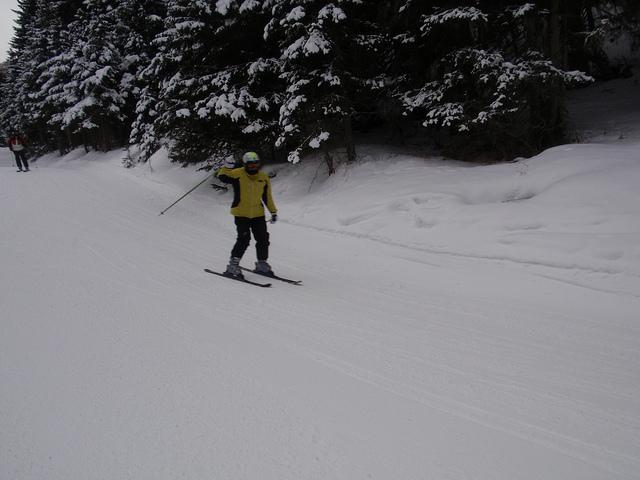What is behind the person?
Short answer required. Trees. What color is this person's jacket?
Concise answer only. Yellow. Is this a ski slope?
Write a very short answer. Yes. What color is the persons coat?
Quick response, please. Yellow. Is there evidence of electricity?
Short answer required. No. What is the color of the man's cap?
Keep it brief. White. How many people are in the picture?
Keep it brief. 2. Is this fresh undisturbed snow?
Keep it brief. No. Is the visibility very clear in this photo?
Short answer required. Yes. What color jacket is the person wearing?
Give a very brief answer. Yellow. What is the man doing in this picture?
Write a very short answer. Skiing. What is the most colorful item in this picture?
Answer briefly. Jacket. 